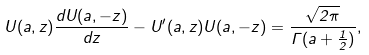<formula> <loc_0><loc_0><loc_500><loc_500>U ( a , z ) \frac { d U ( a , - z ) } { d z } - U ^ { \prime } ( a , z ) U ( a , - z ) = \frac { \sqrt { 2 \pi } } { \Gamma ( a + \frac { 1 } { 2 } ) } ,</formula> 